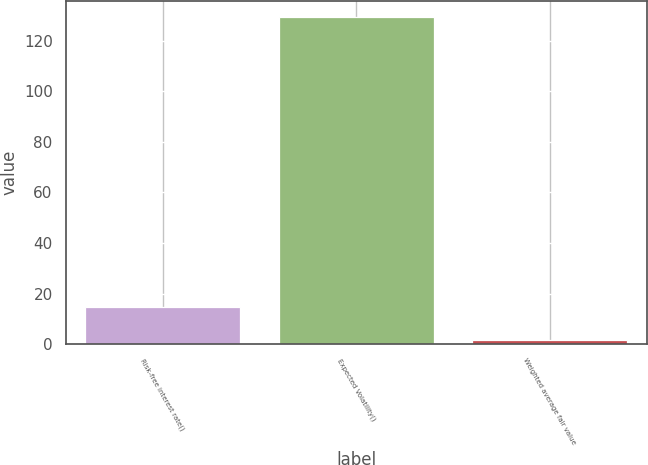<chart> <loc_0><loc_0><loc_500><loc_500><bar_chart><fcel>Risk-free interest rate()<fcel>Expected Volatility()<fcel>Weighted average fair value<nl><fcel>14.5<fcel>129.2<fcel>1.76<nl></chart> 